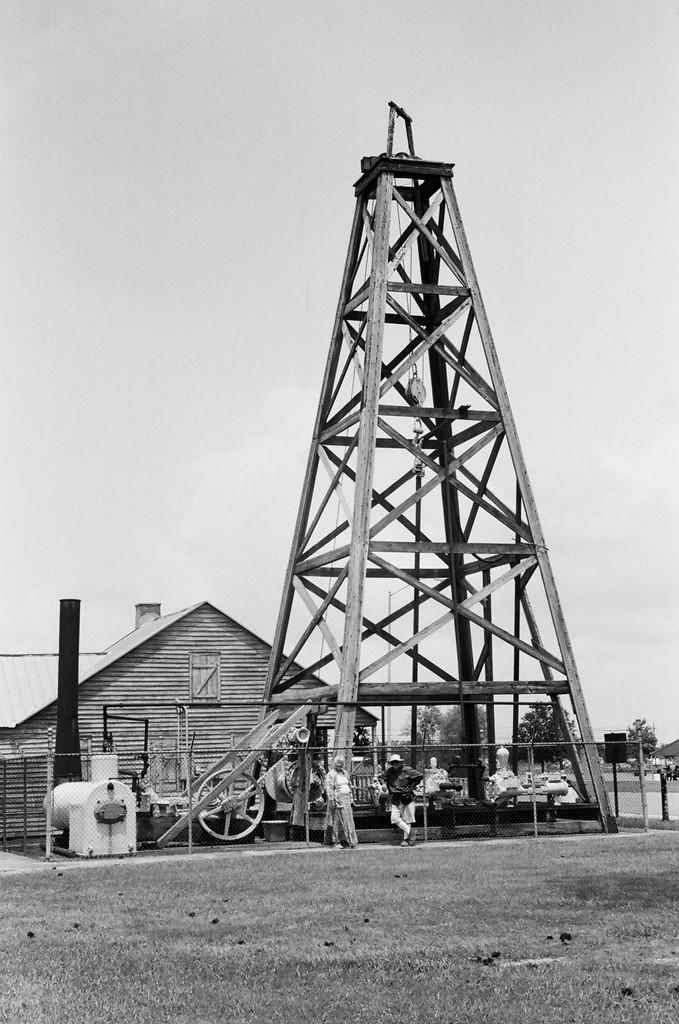What is the color scheme of the image? The image is black and white. What structures can be seen in the image? There is a tower and a house in the image. What other objects are present in the image? There are poles, people, a wheel, and a walkway in the image. Additionally, there are a few unspecified objects. What can be seen in the background of the image? There are trees and the sky visible in the background of the image. What type of print can be seen on the team's uniforms in the image? There is no team or uniforms present in the image; it features a tower, a house, and other objects. Can you tell me how many airplanes are visible in the image? There are no airplanes or airports present in the image. 